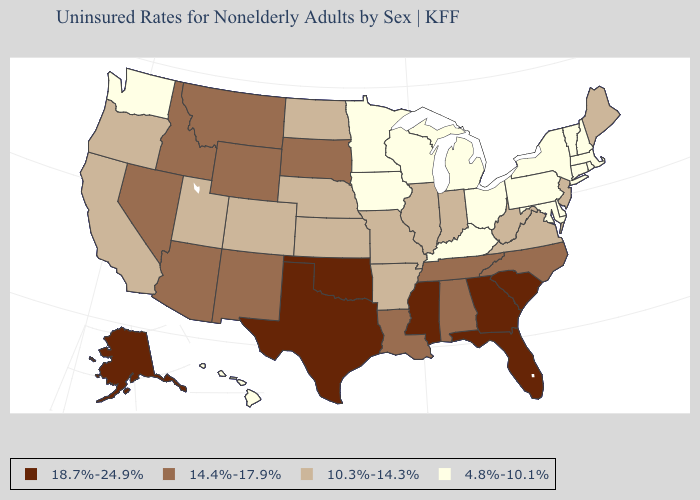Which states have the lowest value in the USA?
Quick response, please. Connecticut, Delaware, Hawaii, Iowa, Kentucky, Maryland, Massachusetts, Michigan, Minnesota, New Hampshire, New York, Ohio, Pennsylvania, Rhode Island, Vermont, Washington, Wisconsin. Name the states that have a value in the range 14.4%-17.9%?
Keep it brief. Alabama, Arizona, Idaho, Louisiana, Montana, Nevada, New Mexico, North Carolina, South Dakota, Tennessee, Wyoming. Which states have the lowest value in the USA?
Short answer required. Connecticut, Delaware, Hawaii, Iowa, Kentucky, Maryland, Massachusetts, Michigan, Minnesota, New Hampshire, New York, Ohio, Pennsylvania, Rhode Island, Vermont, Washington, Wisconsin. What is the value of Mississippi?
Keep it brief. 18.7%-24.9%. What is the lowest value in states that border North Dakota?
Quick response, please. 4.8%-10.1%. Name the states that have a value in the range 18.7%-24.9%?
Short answer required. Alaska, Florida, Georgia, Mississippi, Oklahoma, South Carolina, Texas. Does Maine have the lowest value in the Northeast?
Answer briefly. No. Name the states that have a value in the range 18.7%-24.9%?
Short answer required. Alaska, Florida, Georgia, Mississippi, Oklahoma, South Carolina, Texas. Name the states that have a value in the range 18.7%-24.9%?
Concise answer only. Alaska, Florida, Georgia, Mississippi, Oklahoma, South Carolina, Texas. Does the first symbol in the legend represent the smallest category?
Be succinct. No. Name the states that have a value in the range 4.8%-10.1%?
Concise answer only. Connecticut, Delaware, Hawaii, Iowa, Kentucky, Maryland, Massachusetts, Michigan, Minnesota, New Hampshire, New York, Ohio, Pennsylvania, Rhode Island, Vermont, Washington, Wisconsin. Among the states that border Montana , which have the highest value?
Short answer required. Idaho, South Dakota, Wyoming. Name the states that have a value in the range 10.3%-14.3%?
Answer briefly. Arkansas, California, Colorado, Illinois, Indiana, Kansas, Maine, Missouri, Nebraska, New Jersey, North Dakota, Oregon, Utah, Virginia, West Virginia. Which states hav the highest value in the South?
Write a very short answer. Florida, Georgia, Mississippi, Oklahoma, South Carolina, Texas. What is the value of Delaware?
Short answer required. 4.8%-10.1%. 